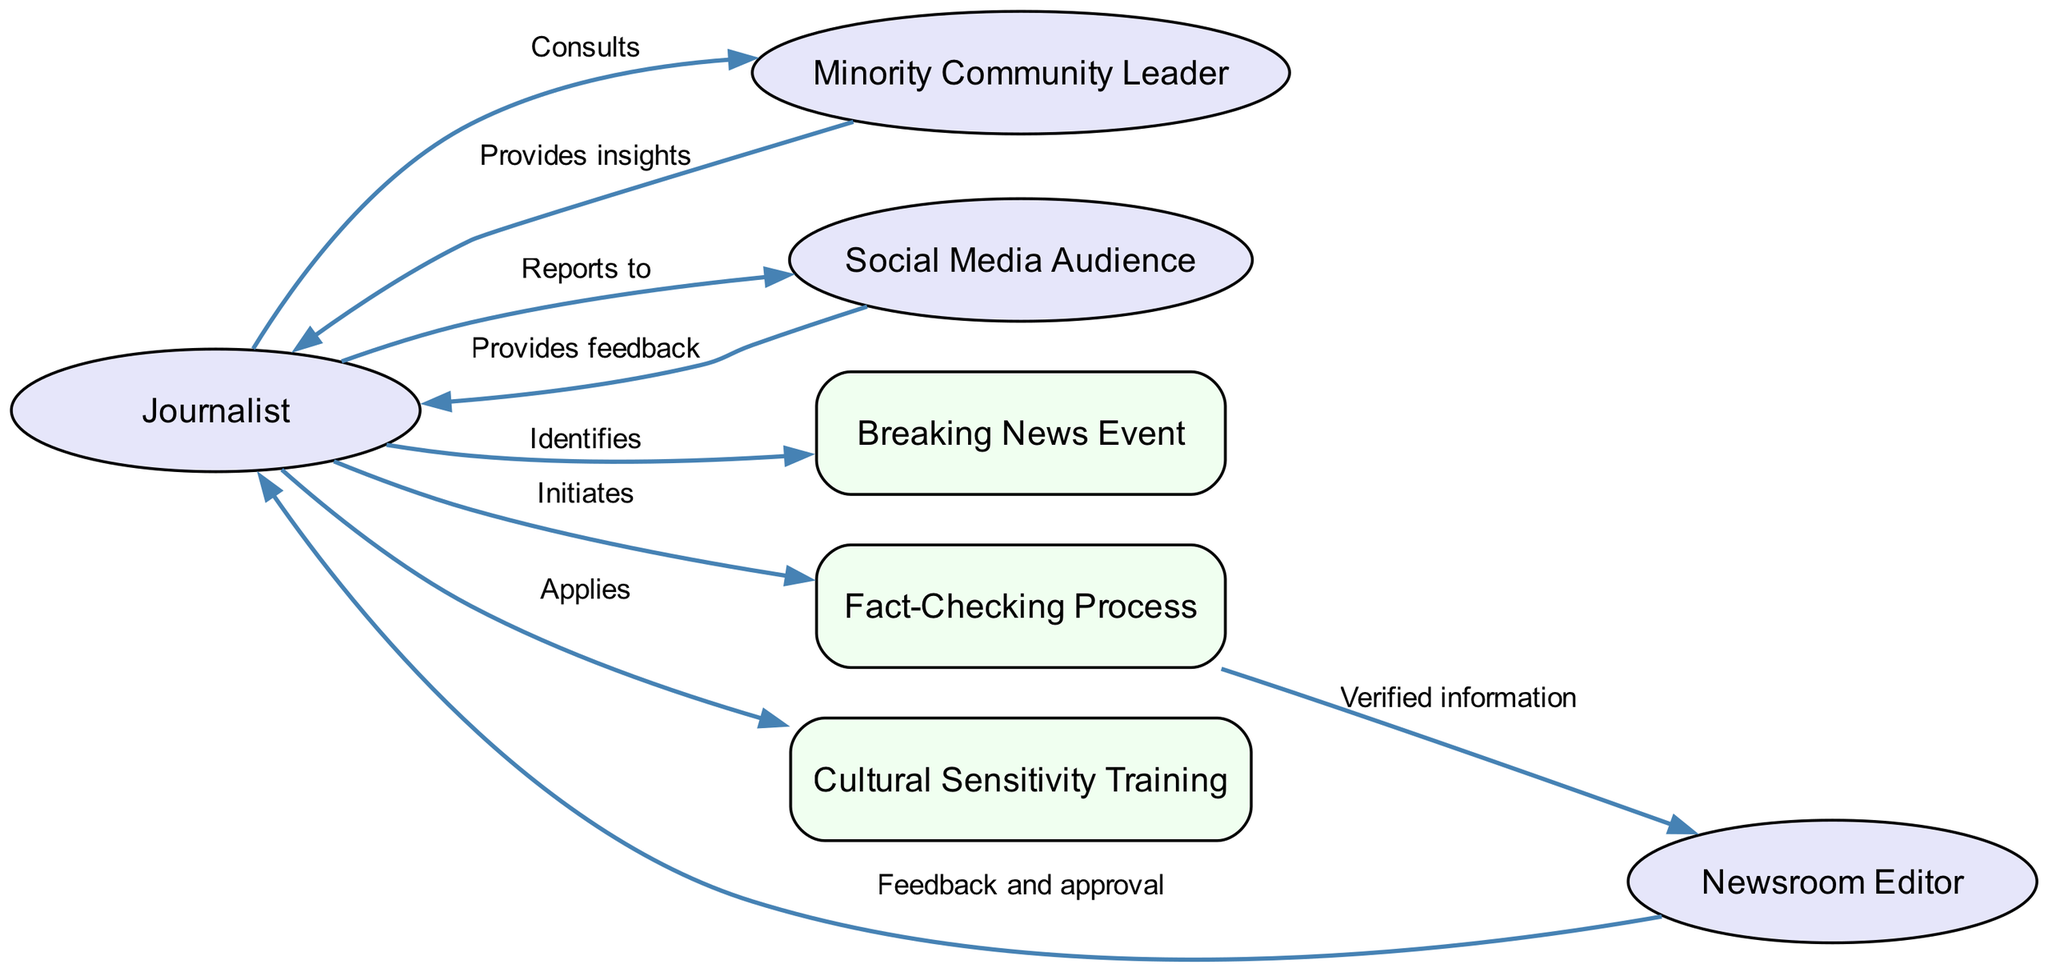What is the starting actor in the communication flow? The starting actor is the Journalist, as depicted in the diagram who initiates the communication process by identifying the breaking news event.
Answer: Journalist How many actors are represented in the diagram? There are four actors represented in the diagram, which include the Journalist, Minority Community Leader, Newsroom Editor, and Social Media Audience. I counted them directly in the visual representation.
Answer: 4 What action does the Journalist take after consulting the Minority Community Leader? After consulting the Minority Community Leader, the Journalist initiates the Fact-Checking Process to verify the information before publication. This step is clearly outlined in the flow of the diagram.
Answer: Initiates What is the final audience that receives the report? The final audience that receives the report is the Social Media Audience, who interact with the news through various platforms as indicated in the communication flow.
Answer: Social Media Audience What relationship exists between the Minority Community Leader and the Journalist? The relationship is one of consultation and insight provision; the Journalist consults the Minority Community Leader, who in return provides insights. This is indicated by arrows showing the direction of communication.
Answer: Consults and Provides insights In what stage of the process does the Newsroom Editor become involved? The Newsroom Editor becomes involved after the Journalist initiates the Fact-Checking Process and receives verified information from it. This is a sequential step in the communication flow depicted in the diagram.
Answer: After Fact-Checking Process What guideline does the Journalist apply to ensure respectful reporting? The Journalist applies Cultural Sensitivity Training, which ensures that the perspectives of minority groups are reported respectfully. The flow shows this application step following interactions with the community leader.
Answer: Cultural Sensitivity Training Who gives feedback to the Journalist after the Newsroom Editor? The Social Media Audience provides feedback to the Journalist after receiving the report. This feedback loop is represented graphically in the sequence of interactions.
Answer: Social Media Audience 